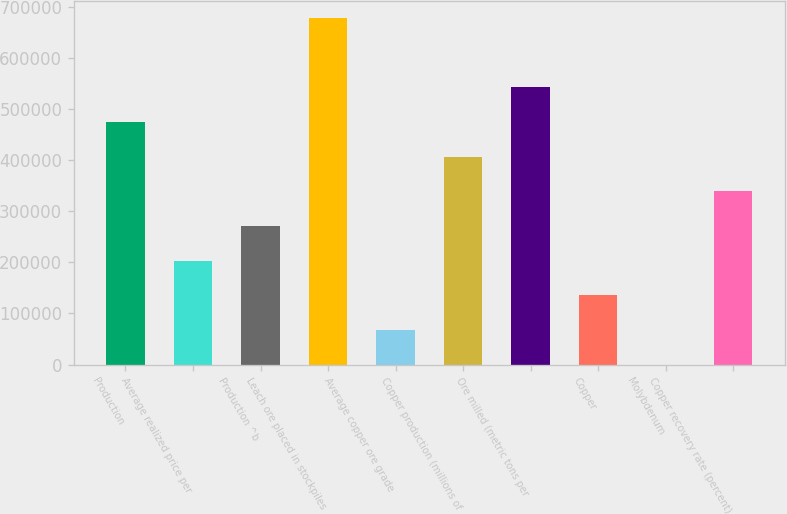Convert chart to OTSL. <chart><loc_0><loc_0><loc_500><loc_500><bar_chart><fcel>Production<fcel>Average realized price per<fcel>Production ^b<fcel>Leach ore placed in stockpiles<fcel>Average copper ore grade<fcel>Copper production (millions of<fcel>Ore milled (metric tons per<fcel>Copper<fcel>Molybdenum<fcel>Copper recovery rate (percent)<nl><fcel>475300<fcel>203700<fcel>271600<fcel>679000<fcel>67900<fcel>407400<fcel>543200<fcel>135800<fcel>0.03<fcel>339500<nl></chart> 